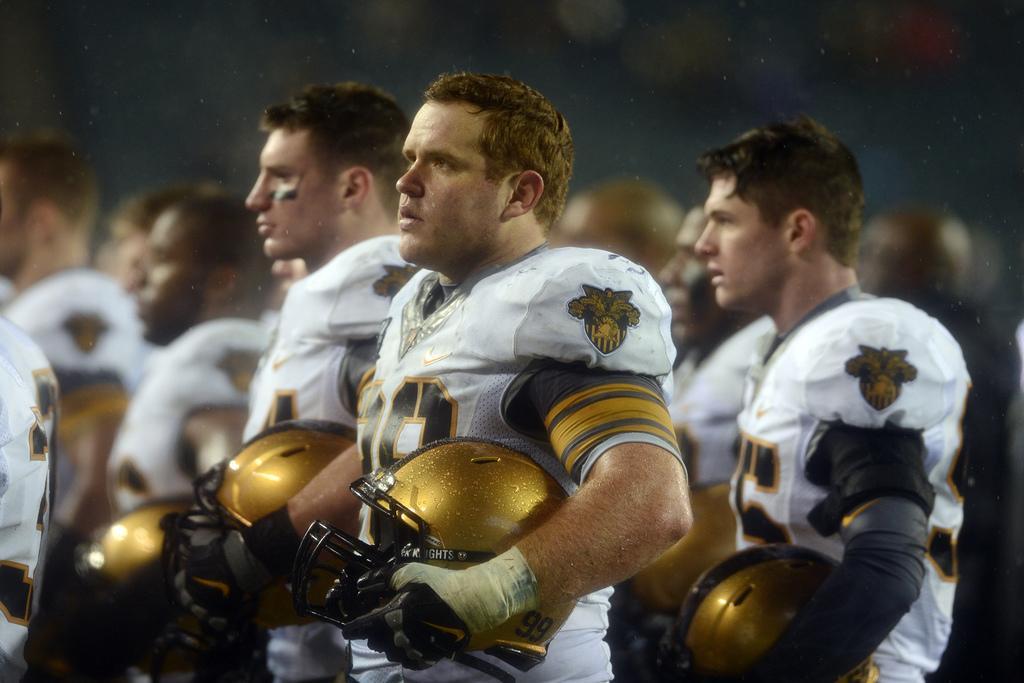Please provide a concise description of this image. In this picture we can see the group of persons wearing white color dresses, holding helmets and standing. In the background we can see the group of persons and some other objects. 